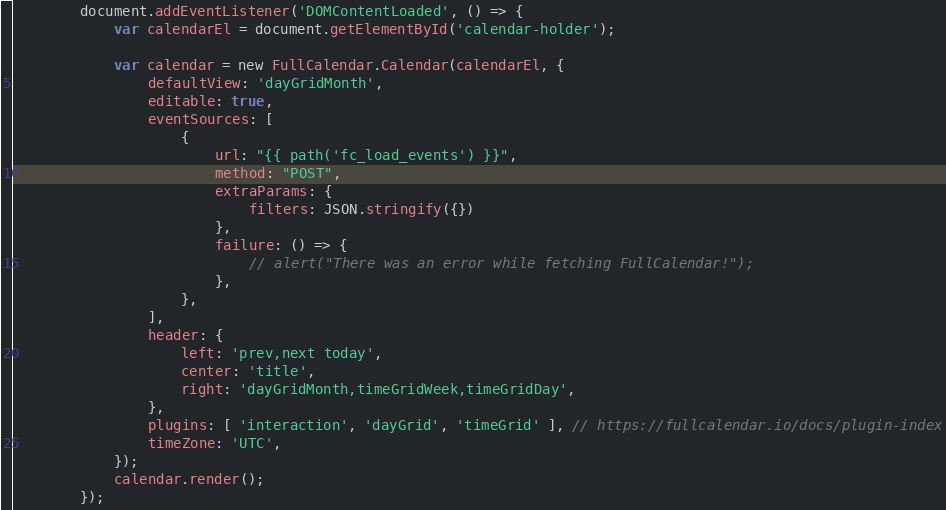<code> <loc_0><loc_0><loc_500><loc_500><_JavaScript_>
        document.addEventListener('DOMContentLoaded', () => {
            var calendarEl = document.getElementById('calendar-holder');

            var calendar = new FullCalendar.Calendar(calendarEl, {
                defaultView: 'dayGridMonth',
                editable: true,
                eventSources: [
                    {
                        url: "{{ path('fc_load_events') }}",
                        method: "POST",
                        extraParams: {
                            filters: JSON.stringify({})
                        },
                        failure: () => {
                            // alert("There was an error while fetching FullCalendar!");
                        },
                    },
                ],
                header: {
                    left: 'prev,next today',
                    center: 'title',
                    right: 'dayGridMonth,timeGridWeek,timeGridDay',
                },
                plugins: [ 'interaction', 'dayGrid', 'timeGrid' ], // https://fullcalendar.io/docs/plugin-index
                timeZone: 'UTC',
            });
            calendar.render();
        });
</code> 